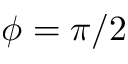Convert formula to latex. <formula><loc_0><loc_0><loc_500><loc_500>\phi = \pi / 2</formula> 